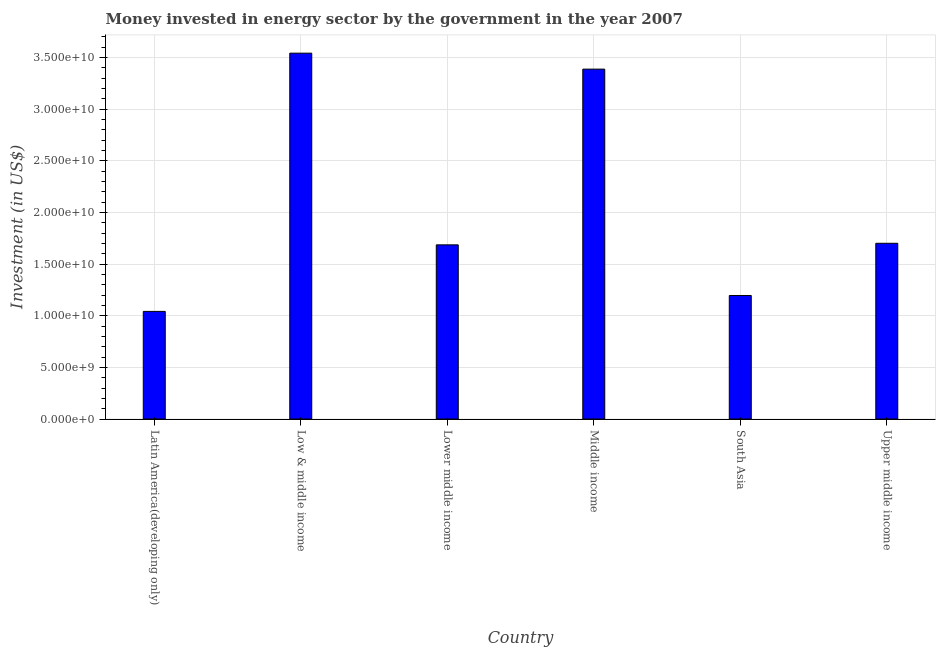Does the graph contain any zero values?
Provide a succinct answer. No. Does the graph contain grids?
Make the answer very short. Yes. What is the title of the graph?
Your answer should be compact. Money invested in energy sector by the government in the year 2007. What is the label or title of the Y-axis?
Your response must be concise. Investment (in US$). What is the investment in energy in South Asia?
Ensure brevity in your answer.  1.20e+1. Across all countries, what is the maximum investment in energy?
Offer a very short reply. 3.54e+1. Across all countries, what is the minimum investment in energy?
Make the answer very short. 1.04e+1. In which country was the investment in energy maximum?
Offer a very short reply. Low & middle income. In which country was the investment in energy minimum?
Offer a very short reply. Latin America(developing only). What is the sum of the investment in energy?
Offer a terse response. 1.26e+11. What is the difference between the investment in energy in Low & middle income and Middle income?
Provide a short and direct response. 1.55e+09. What is the average investment in energy per country?
Give a very brief answer. 2.09e+1. What is the median investment in energy?
Your answer should be very brief. 1.69e+1. In how many countries, is the investment in energy greater than 16000000000 US$?
Offer a terse response. 4. What is the ratio of the investment in energy in Middle income to that in South Asia?
Your response must be concise. 2.83. Is the investment in energy in Latin America(developing only) less than that in Lower middle income?
Provide a succinct answer. Yes. Is the difference between the investment in energy in Low & middle income and Middle income greater than the difference between any two countries?
Ensure brevity in your answer.  No. What is the difference between the highest and the second highest investment in energy?
Give a very brief answer. 1.55e+09. What is the difference between the highest and the lowest investment in energy?
Ensure brevity in your answer.  2.50e+1. How many bars are there?
Keep it short and to the point. 6. How many countries are there in the graph?
Provide a succinct answer. 6. Are the values on the major ticks of Y-axis written in scientific E-notation?
Give a very brief answer. Yes. What is the Investment (in US$) in Latin America(developing only)?
Offer a very short reply. 1.04e+1. What is the Investment (in US$) in Low & middle income?
Ensure brevity in your answer.  3.54e+1. What is the Investment (in US$) in Lower middle income?
Your answer should be very brief. 1.69e+1. What is the Investment (in US$) in Middle income?
Your response must be concise. 3.39e+1. What is the Investment (in US$) of South Asia?
Your response must be concise. 1.20e+1. What is the Investment (in US$) of Upper middle income?
Your answer should be very brief. 1.70e+1. What is the difference between the Investment (in US$) in Latin America(developing only) and Low & middle income?
Provide a short and direct response. -2.50e+1. What is the difference between the Investment (in US$) in Latin America(developing only) and Lower middle income?
Offer a terse response. -6.44e+09. What is the difference between the Investment (in US$) in Latin America(developing only) and Middle income?
Your response must be concise. -2.35e+1. What is the difference between the Investment (in US$) in Latin America(developing only) and South Asia?
Your answer should be compact. -1.54e+09. What is the difference between the Investment (in US$) in Latin America(developing only) and Upper middle income?
Your answer should be very brief. -6.60e+09. What is the difference between the Investment (in US$) in Low & middle income and Lower middle income?
Your response must be concise. 1.86e+1. What is the difference between the Investment (in US$) in Low & middle income and Middle income?
Provide a short and direct response. 1.55e+09. What is the difference between the Investment (in US$) in Low & middle income and South Asia?
Offer a terse response. 2.35e+1. What is the difference between the Investment (in US$) in Low & middle income and Upper middle income?
Ensure brevity in your answer.  1.84e+1. What is the difference between the Investment (in US$) in Lower middle income and Middle income?
Give a very brief answer. -1.70e+1. What is the difference between the Investment (in US$) in Lower middle income and South Asia?
Your answer should be very brief. 4.90e+09. What is the difference between the Investment (in US$) in Lower middle income and Upper middle income?
Keep it short and to the point. -1.52e+08. What is the difference between the Investment (in US$) in Middle income and South Asia?
Offer a very short reply. 2.19e+1. What is the difference between the Investment (in US$) in Middle income and Upper middle income?
Your answer should be very brief. 1.69e+1. What is the difference between the Investment (in US$) in South Asia and Upper middle income?
Offer a terse response. -5.06e+09. What is the ratio of the Investment (in US$) in Latin America(developing only) to that in Low & middle income?
Provide a short and direct response. 0.29. What is the ratio of the Investment (in US$) in Latin America(developing only) to that in Lower middle income?
Keep it short and to the point. 0.62. What is the ratio of the Investment (in US$) in Latin America(developing only) to that in Middle income?
Keep it short and to the point. 0.31. What is the ratio of the Investment (in US$) in Latin America(developing only) to that in South Asia?
Provide a succinct answer. 0.87. What is the ratio of the Investment (in US$) in Latin America(developing only) to that in Upper middle income?
Provide a succinct answer. 0.61. What is the ratio of the Investment (in US$) in Low & middle income to that in Lower middle income?
Your answer should be very brief. 2.1. What is the ratio of the Investment (in US$) in Low & middle income to that in Middle income?
Your answer should be compact. 1.05. What is the ratio of the Investment (in US$) in Low & middle income to that in South Asia?
Your answer should be very brief. 2.96. What is the ratio of the Investment (in US$) in Low & middle income to that in Upper middle income?
Offer a very short reply. 2.08. What is the ratio of the Investment (in US$) in Lower middle income to that in Middle income?
Your answer should be very brief. 0.5. What is the ratio of the Investment (in US$) in Lower middle income to that in South Asia?
Provide a succinct answer. 1.41. What is the ratio of the Investment (in US$) in Lower middle income to that in Upper middle income?
Offer a terse response. 0.99. What is the ratio of the Investment (in US$) in Middle income to that in South Asia?
Provide a short and direct response. 2.83. What is the ratio of the Investment (in US$) in Middle income to that in Upper middle income?
Give a very brief answer. 1.99. What is the ratio of the Investment (in US$) in South Asia to that in Upper middle income?
Keep it short and to the point. 0.7. 